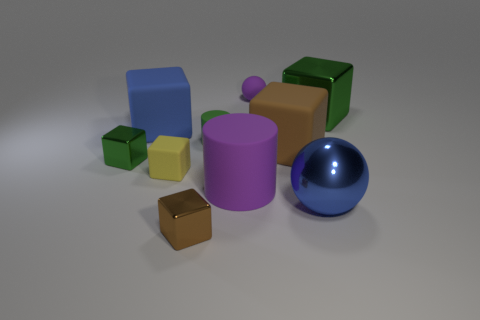Which is the largest object and what color is it? The largest object is a green cube, which has a vivid green hue, similar to the color of a lime. 